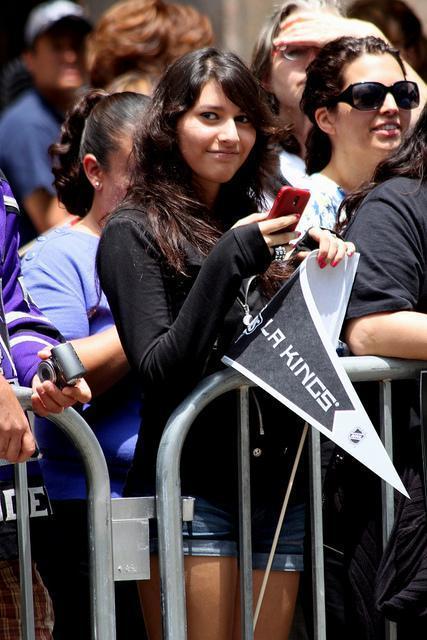How many people are in the photo?
Give a very brief answer. 8. 